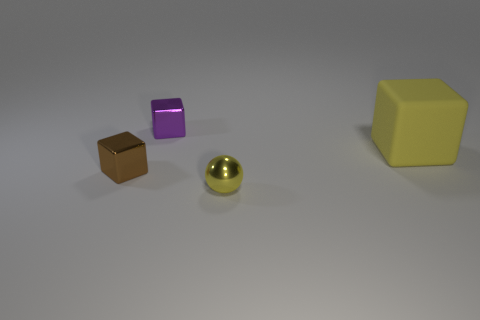Add 2 large yellow objects. How many objects exist? 6 Subtract all small brown shiny blocks. How many blocks are left? 2 Subtract all spheres. How many objects are left? 3 Subtract all brown cubes. How many cubes are left? 2 Add 2 purple objects. How many purple objects are left? 3 Add 2 cyan objects. How many cyan objects exist? 2 Subtract 0 blue blocks. How many objects are left? 4 Subtract all cyan blocks. Subtract all purple balls. How many blocks are left? 3 Subtract all small purple shiny cubes. Subtract all tiny brown metallic objects. How many objects are left? 2 